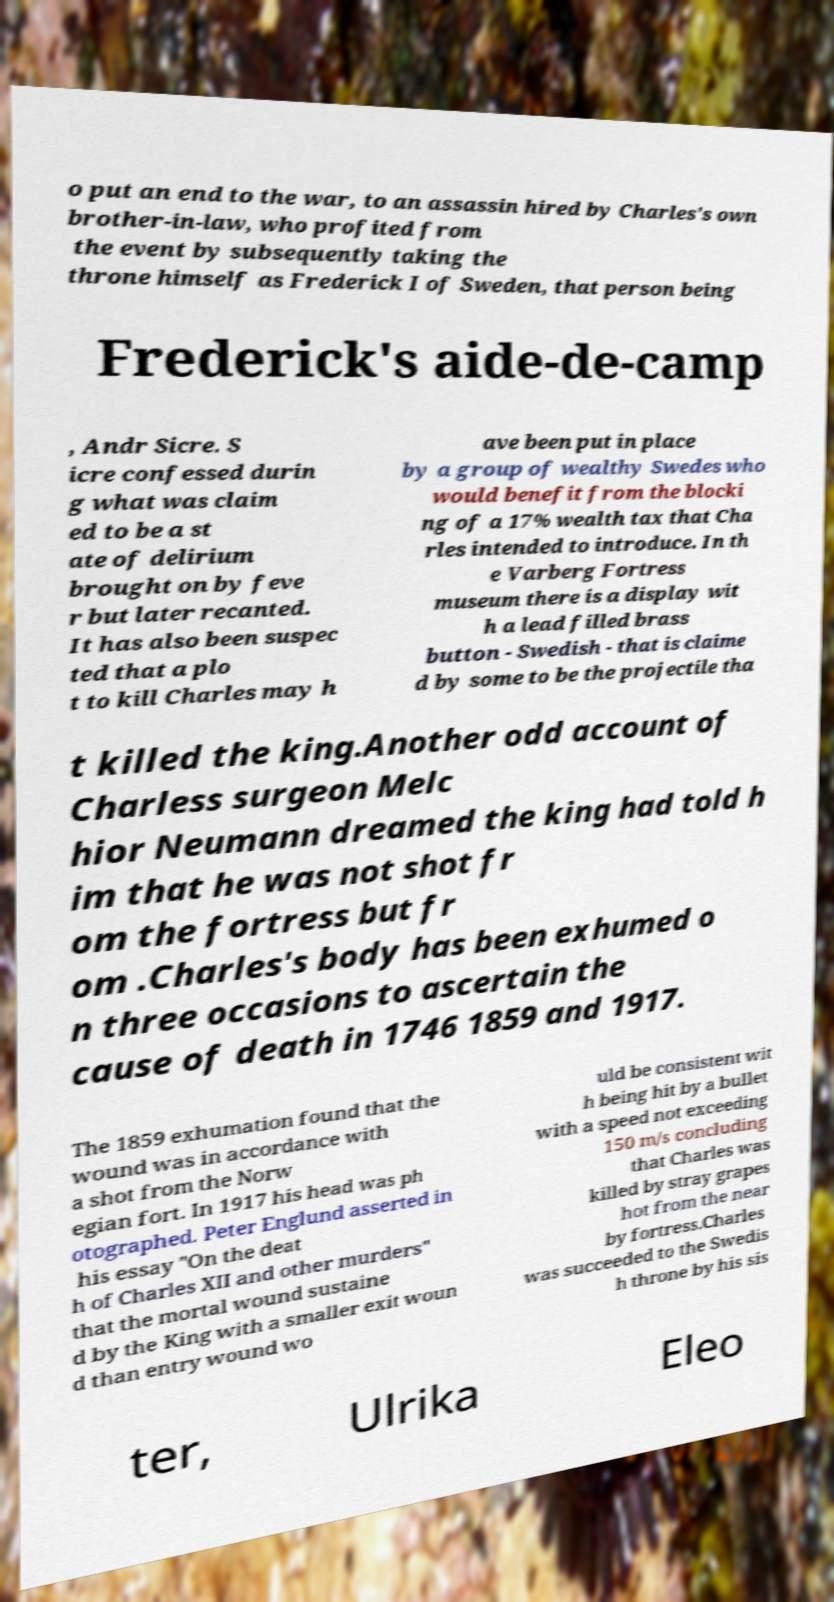Please read and relay the text visible in this image. What does it say? o put an end to the war, to an assassin hired by Charles's own brother-in-law, who profited from the event by subsequently taking the throne himself as Frederick I of Sweden, that person being Frederick's aide-de-camp , Andr Sicre. S icre confessed durin g what was claim ed to be a st ate of delirium brought on by feve r but later recanted. It has also been suspec ted that a plo t to kill Charles may h ave been put in place by a group of wealthy Swedes who would benefit from the blocki ng of a 17% wealth tax that Cha rles intended to introduce. In th e Varberg Fortress museum there is a display wit h a lead filled brass button - Swedish - that is claime d by some to be the projectile tha t killed the king.Another odd account of Charless surgeon Melc hior Neumann dreamed the king had told h im that he was not shot fr om the fortress but fr om .Charles's body has been exhumed o n three occasions to ascertain the cause of death in 1746 1859 and 1917. The 1859 exhumation found that the wound was in accordance with a shot from the Norw egian fort. In 1917 his head was ph otographed. Peter Englund asserted in his essay "On the deat h of Charles XII and other murders" that the mortal wound sustaine d by the King with a smaller exit woun d than entry wound wo uld be consistent wit h being hit by a bullet with a speed not exceeding 150 m/s concluding that Charles was killed by stray grapes hot from the near by fortress.Charles was succeeded to the Swedis h throne by his sis ter, Ulrika Eleo 